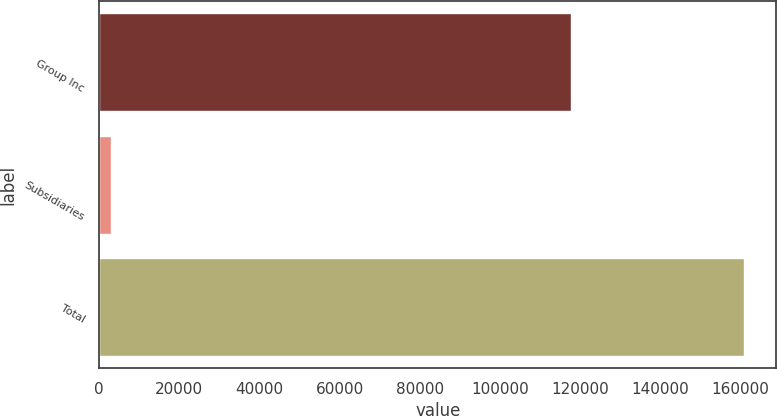<chart> <loc_0><loc_0><loc_500><loc_500><bar_chart><fcel>Group Inc<fcel>Subsidiaries<fcel>Total<nl><fcel>117899<fcel>2967<fcel>160965<nl></chart> 